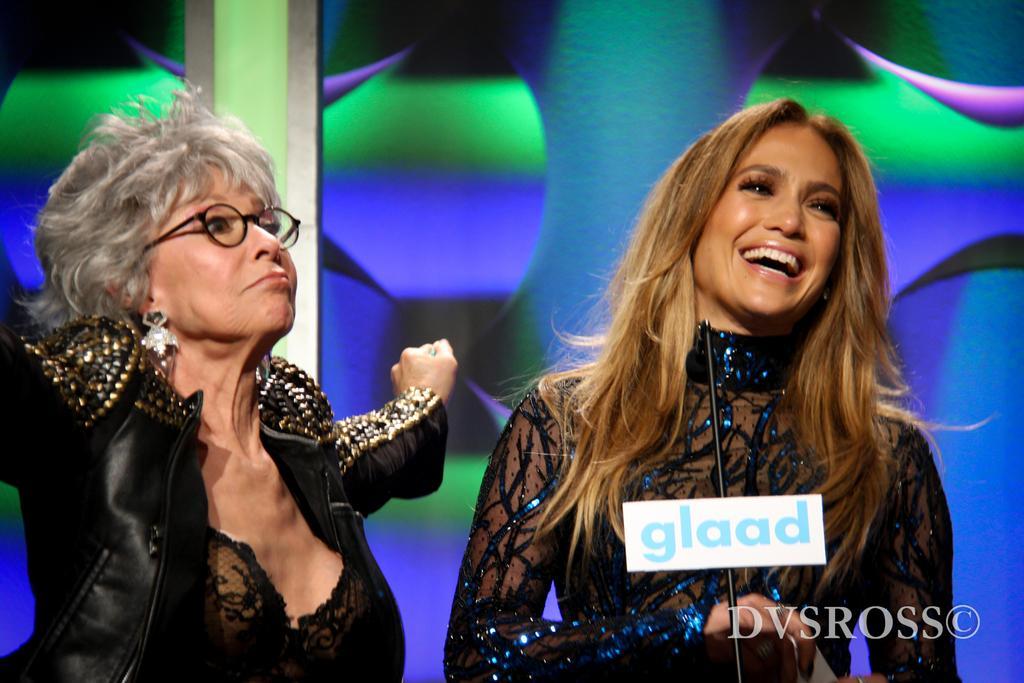Please provide a concise description of this image. In this picture I can see couple of women standing and I can see a woman with a smile on her face and I can see a microphone and text at the bottom right corner of the picture and I can see colorful background. 